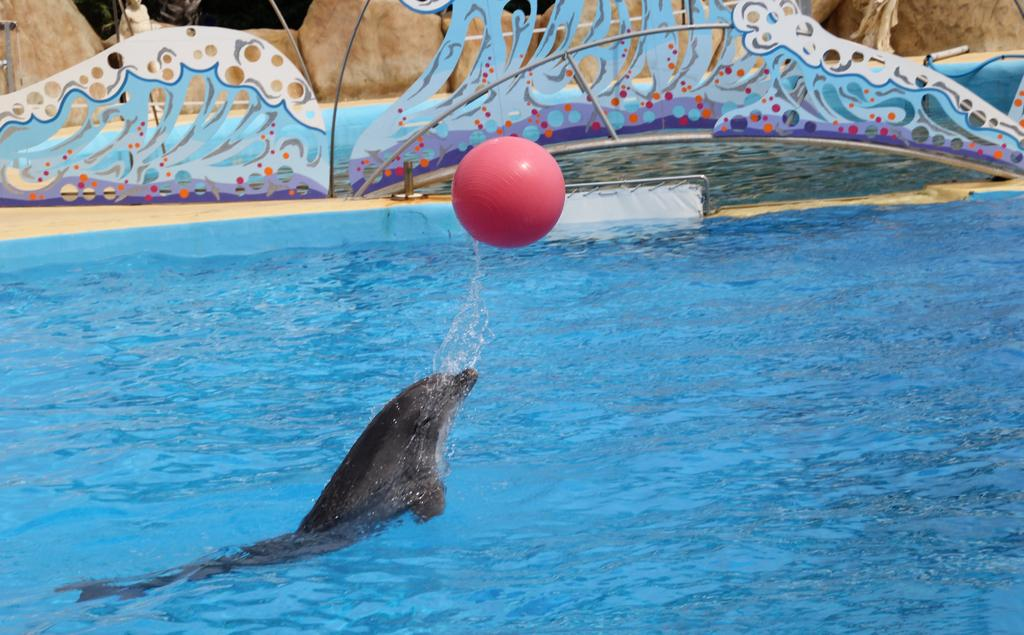What is the primary element in the image? There is water in the image. What type of animal can be seen in the water? There is a dolphin in the water. What object is present in the image besides the water and dolphin? There is a ball in the image. What can be seen in the background of the image? There are decorative items and a wall in the background. How many pizzas are being eaten by the dolphin in the image? There are no pizzas present in the image; it features a dolphin in the water. What color is the dolphin's tongue in the image? There is no visible tongue on the dolphin in the image. 